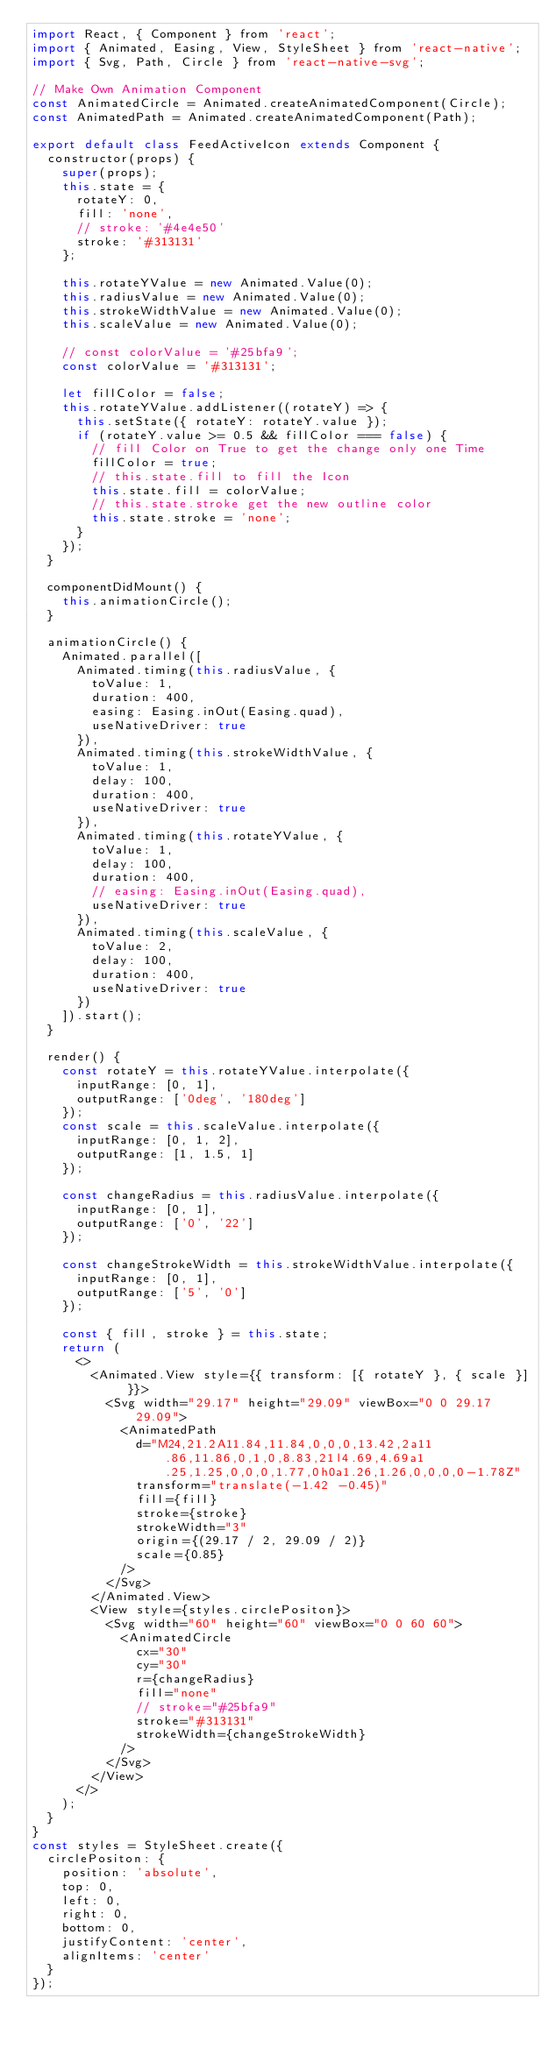<code> <loc_0><loc_0><loc_500><loc_500><_JavaScript_>import React, { Component } from 'react';
import { Animated, Easing, View, StyleSheet } from 'react-native';
import { Svg, Path, Circle } from 'react-native-svg';

// Make Own Animation Component
const AnimatedCircle = Animated.createAnimatedComponent(Circle);
const AnimatedPath = Animated.createAnimatedComponent(Path);

export default class FeedActiveIcon extends Component {
  constructor(props) {
    super(props);
    this.state = {
      rotateY: 0,
      fill: 'none',
      // stroke: '#4e4e50'
      stroke: '#313131'
    };

    this.rotateYValue = new Animated.Value(0);
    this.radiusValue = new Animated.Value(0);
    this.strokeWidthValue = new Animated.Value(0);
    this.scaleValue = new Animated.Value(0);

    // const colorValue = '#25bfa9';
    const colorValue = '#313131';

    let fillColor = false;
    this.rotateYValue.addListener((rotateY) => {
      this.setState({ rotateY: rotateY.value });
      if (rotateY.value >= 0.5 && fillColor === false) {
        // fill Color on True to get the change only one Time
        fillColor = true;
        // this.state.fill to fill the Icon
        this.state.fill = colorValue;
        // this.state.stroke get the new outline color
        this.state.stroke = 'none';
      }
    });
  }

  componentDidMount() {
    this.animationCircle();
  }

  animationCircle() {
    Animated.parallel([
      Animated.timing(this.radiusValue, {
        toValue: 1,
        duration: 400,
        easing: Easing.inOut(Easing.quad),
        useNativeDriver: true
      }),
      Animated.timing(this.strokeWidthValue, {
        toValue: 1,
        delay: 100,
        duration: 400,
        useNativeDriver: true
      }),
      Animated.timing(this.rotateYValue, {
        toValue: 1,
        delay: 100,
        duration: 400,
        // easing: Easing.inOut(Easing.quad),
        useNativeDriver: true
      }),
      Animated.timing(this.scaleValue, {
        toValue: 2,
        delay: 100,
        duration: 400,
        useNativeDriver: true
      })
    ]).start();
  }

  render() {
    const rotateY = this.rotateYValue.interpolate({
      inputRange: [0, 1],
      outputRange: ['0deg', '180deg']
    });
    const scale = this.scaleValue.interpolate({
      inputRange: [0, 1, 2],
      outputRange: [1, 1.5, 1]
    });

    const changeRadius = this.radiusValue.interpolate({
      inputRange: [0, 1],
      outputRange: ['0', '22']
    });

    const changeStrokeWidth = this.strokeWidthValue.interpolate({
      inputRange: [0, 1],
      outputRange: ['5', '0']
    });

    const { fill, stroke } = this.state;
    return (
      <>
        <Animated.View style={{ transform: [{ rotateY }, { scale }] }}>
          <Svg width="29.17" height="29.09" viewBox="0 0 29.17 29.09">
            <AnimatedPath
              d="M24,21.2A11.84,11.84,0,0,0,13.42,2a11.86,11.86,0,1,0,8.83,21l4.69,4.69a1.25,1.25,0,0,0,1.77,0h0a1.26,1.26,0,0,0,0-1.78Z"
              transform="translate(-1.42 -0.45)"
              fill={fill}
              stroke={stroke}
              strokeWidth="3"
              origin={(29.17 / 2, 29.09 / 2)}
              scale={0.85}
            />
          </Svg>
        </Animated.View>
        <View style={styles.circlePositon}>
          <Svg width="60" height="60" viewBox="0 0 60 60">
            <AnimatedCircle
              cx="30"
              cy="30"
              r={changeRadius}
              fill="none"
              // stroke="#25bfa9"
              stroke="#313131"
              strokeWidth={changeStrokeWidth}
            />
          </Svg>
        </View>
      </>
    );
  }
}
const styles = StyleSheet.create({
  circlePositon: {
    position: 'absolute',
    top: 0,
    left: 0,
    right: 0,
    bottom: 0,
    justifyContent: 'center',
    alignItems: 'center'
  }
});
</code> 